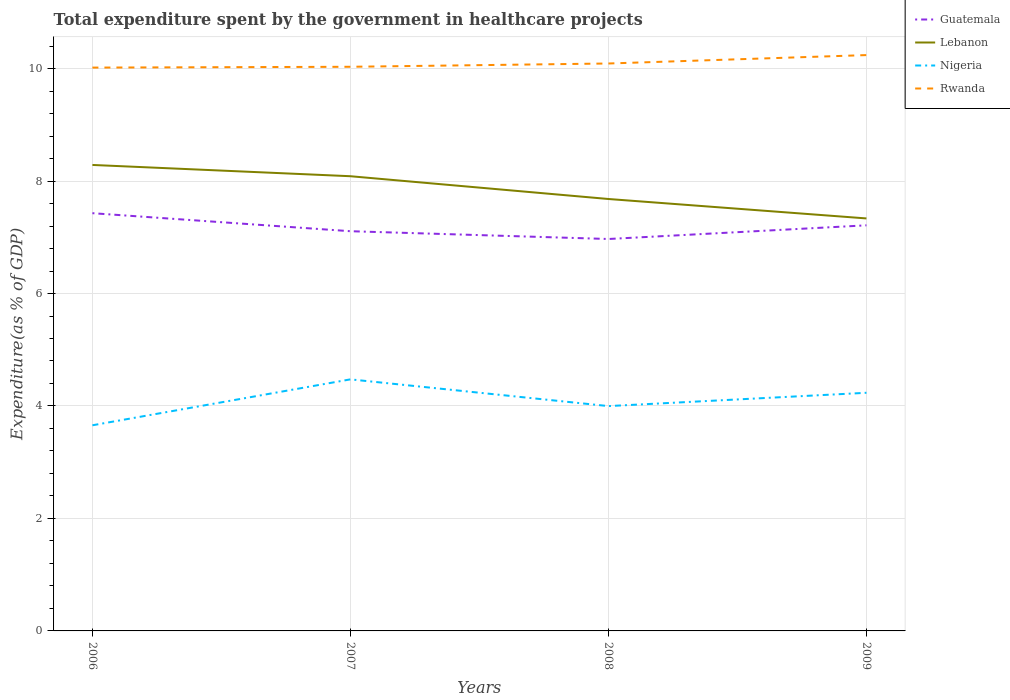Does the line corresponding to Lebanon intersect with the line corresponding to Guatemala?
Give a very brief answer. No. Is the number of lines equal to the number of legend labels?
Offer a terse response. Yes. Across all years, what is the maximum total expenditure spent by the government in healthcare projects in Guatemala?
Give a very brief answer. 6.97. What is the total total expenditure spent by the government in healthcare projects in Guatemala in the graph?
Provide a succinct answer. 0.14. What is the difference between the highest and the second highest total expenditure spent by the government in healthcare projects in Rwanda?
Make the answer very short. 0.22. What is the difference between the highest and the lowest total expenditure spent by the government in healthcare projects in Guatemala?
Make the answer very short. 2. Is the total expenditure spent by the government in healthcare projects in Rwanda strictly greater than the total expenditure spent by the government in healthcare projects in Guatemala over the years?
Ensure brevity in your answer.  No. How many years are there in the graph?
Make the answer very short. 4. Are the values on the major ticks of Y-axis written in scientific E-notation?
Ensure brevity in your answer.  No. Does the graph contain any zero values?
Give a very brief answer. No. Does the graph contain grids?
Your response must be concise. Yes. Where does the legend appear in the graph?
Your answer should be compact. Top right. How are the legend labels stacked?
Provide a short and direct response. Vertical. What is the title of the graph?
Offer a terse response. Total expenditure spent by the government in healthcare projects. Does "Vanuatu" appear as one of the legend labels in the graph?
Offer a terse response. No. What is the label or title of the X-axis?
Keep it short and to the point. Years. What is the label or title of the Y-axis?
Your response must be concise. Expenditure(as % of GDP). What is the Expenditure(as % of GDP) of Guatemala in 2006?
Make the answer very short. 7.43. What is the Expenditure(as % of GDP) in Lebanon in 2006?
Keep it short and to the point. 8.29. What is the Expenditure(as % of GDP) in Nigeria in 2006?
Give a very brief answer. 3.66. What is the Expenditure(as % of GDP) in Rwanda in 2006?
Provide a succinct answer. 10.02. What is the Expenditure(as % of GDP) in Guatemala in 2007?
Make the answer very short. 7.11. What is the Expenditure(as % of GDP) of Lebanon in 2007?
Make the answer very short. 8.09. What is the Expenditure(as % of GDP) in Nigeria in 2007?
Provide a short and direct response. 4.47. What is the Expenditure(as % of GDP) of Rwanda in 2007?
Your response must be concise. 10.03. What is the Expenditure(as % of GDP) in Guatemala in 2008?
Keep it short and to the point. 6.97. What is the Expenditure(as % of GDP) of Lebanon in 2008?
Give a very brief answer. 7.68. What is the Expenditure(as % of GDP) of Nigeria in 2008?
Ensure brevity in your answer.  4. What is the Expenditure(as % of GDP) in Rwanda in 2008?
Provide a short and direct response. 10.09. What is the Expenditure(as % of GDP) of Guatemala in 2009?
Your answer should be very brief. 7.21. What is the Expenditure(as % of GDP) in Lebanon in 2009?
Provide a succinct answer. 7.34. What is the Expenditure(as % of GDP) of Nigeria in 2009?
Make the answer very short. 4.23. What is the Expenditure(as % of GDP) in Rwanda in 2009?
Offer a terse response. 10.24. Across all years, what is the maximum Expenditure(as % of GDP) of Guatemala?
Make the answer very short. 7.43. Across all years, what is the maximum Expenditure(as % of GDP) in Lebanon?
Give a very brief answer. 8.29. Across all years, what is the maximum Expenditure(as % of GDP) of Nigeria?
Make the answer very short. 4.47. Across all years, what is the maximum Expenditure(as % of GDP) of Rwanda?
Your answer should be compact. 10.24. Across all years, what is the minimum Expenditure(as % of GDP) of Guatemala?
Give a very brief answer. 6.97. Across all years, what is the minimum Expenditure(as % of GDP) in Lebanon?
Keep it short and to the point. 7.34. Across all years, what is the minimum Expenditure(as % of GDP) of Nigeria?
Offer a very short reply. 3.66. Across all years, what is the minimum Expenditure(as % of GDP) of Rwanda?
Make the answer very short. 10.02. What is the total Expenditure(as % of GDP) of Guatemala in the graph?
Provide a short and direct response. 28.72. What is the total Expenditure(as % of GDP) of Lebanon in the graph?
Offer a very short reply. 31.39. What is the total Expenditure(as % of GDP) in Nigeria in the graph?
Provide a short and direct response. 16.36. What is the total Expenditure(as % of GDP) of Rwanda in the graph?
Keep it short and to the point. 40.38. What is the difference between the Expenditure(as % of GDP) in Guatemala in 2006 and that in 2007?
Provide a succinct answer. 0.32. What is the difference between the Expenditure(as % of GDP) in Lebanon in 2006 and that in 2007?
Ensure brevity in your answer.  0.2. What is the difference between the Expenditure(as % of GDP) of Nigeria in 2006 and that in 2007?
Your answer should be compact. -0.82. What is the difference between the Expenditure(as % of GDP) of Rwanda in 2006 and that in 2007?
Your answer should be compact. -0.01. What is the difference between the Expenditure(as % of GDP) of Guatemala in 2006 and that in 2008?
Keep it short and to the point. 0.46. What is the difference between the Expenditure(as % of GDP) in Lebanon in 2006 and that in 2008?
Provide a succinct answer. 0.61. What is the difference between the Expenditure(as % of GDP) of Nigeria in 2006 and that in 2008?
Provide a succinct answer. -0.34. What is the difference between the Expenditure(as % of GDP) of Rwanda in 2006 and that in 2008?
Provide a short and direct response. -0.07. What is the difference between the Expenditure(as % of GDP) in Guatemala in 2006 and that in 2009?
Your answer should be compact. 0.22. What is the difference between the Expenditure(as % of GDP) in Lebanon in 2006 and that in 2009?
Make the answer very short. 0.95. What is the difference between the Expenditure(as % of GDP) of Nigeria in 2006 and that in 2009?
Make the answer very short. -0.58. What is the difference between the Expenditure(as % of GDP) in Rwanda in 2006 and that in 2009?
Your answer should be very brief. -0.22. What is the difference between the Expenditure(as % of GDP) in Guatemala in 2007 and that in 2008?
Offer a very short reply. 0.14. What is the difference between the Expenditure(as % of GDP) in Lebanon in 2007 and that in 2008?
Your response must be concise. 0.41. What is the difference between the Expenditure(as % of GDP) of Nigeria in 2007 and that in 2008?
Provide a short and direct response. 0.48. What is the difference between the Expenditure(as % of GDP) in Rwanda in 2007 and that in 2008?
Your answer should be compact. -0.06. What is the difference between the Expenditure(as % of GDP) of Guatemala in 2007 and that in 2009?
Offer a terse response. -0.1. What is the difference between the Expenditure(as % of GDP) in Lebanon in 2007 and that in 2009?
Your answer should be compact. 0.75. What is the difference between the Expenditure(as % of GDP) of Nigeria in 2007 and that in 2009?
Ensure brevity in your answer.  0.24. What is the difference between the Expenditure(as % of GDP) of Rwanda in 2007 and that in 2009?
Offer a very short reply. -0.21. What is the difference between the Expenditure(as % of GDP) of Guatemala in 2008 and that in 2009?
Offer a terse response. -0.24. What is the difference between the Expenditure(as % of GDP) of Lebanon in 2008 and that in 2009?
Your answer should be compact. 0.35. What is the difference between the Expenditure(as % of GDP) in Nigeria in 2008 and that in 2009?
Provide a short and direct response. -0.24. What is the difference between the Expenditure(as % of GDP) of Rwanda in 2008 and that in 2009?
Provide a short and direct response. -0.15. What is the difference between the Expenditure(as % of GDP) in Guatemala in 2006 and the Expenditure(as % of GDP) in Lebanon in 2007?
Provide a succinct answer. -0.66. What is the difference between the Expenditure(as % of GDP) of Guatemala in 2006 and the Expenditure(as % of GDP) of Nigeria in 2007?
Give a very brief answer. 2.96. What is the difference between the Expenditure(as % of GDP) of Guatemala in 2006 and the Expenditure(as % of GDP) of Rwanda in 2007?
Your response must be concise. -2.6. What is the difference between the Expenditure(as % of GDP) in Lebanon in 2006 and the Expenditure(as % of GDP) in Nigeria in 2007?
Keep it short and to the point. 3.81. What is the difference between the Expenditure(as % of GDP) in Lebanon in 2006 and the Expenditure(as % of GDP) in Rwanda in 2007?
Your response must be concise. -1.75. What is the difference between the Expenditure(as % of GDP) in Nigeria in 2006 and the Expenditure(as % of GDP) in Rwanda in 2007?
Keep it short and to the point. -6.38. What is the difference between the Expenditure(as % of GDP) in Guatemala in 2006 and the Expenditure(as % of GDP) in Lebanon in 2008?
Ensure brevity in your answer.  -0.25. What is the difference between the Expenditure(as % of GDP) in Guatemala in 2006 and the Expenditure(as % of GDP) in Nigeria in 2008?
Offer a terse response. 3.43. What is the difference between the Expenditure(as % of GDP) in Guatemala in 2006 and the Expenditure(as % of GDP) in Rwanda in 2008?
Offer a very short reply. -2.66. What is the difference between the Expenditure(as % of GDP) of Lebanon in 2006 and the Expenditure(as % of GDP) of Nigeria in 2008?
Your answer should be very brief. 4.29. What is the difference between the Expenditure(as % of GDP) of Lebanon in 2006 and the Expenditure(as % of GDP) of Rwanda in 2008?
Your answer should be compact. -1.8. What is the difference between the Expenditure(as % of GDP) in Nigeria in 2006 and the Expenditure(as % of GDP) in Rwanda in 2008?
Make the answer very short. -6.43. What is the difference between the Expenditure(as % of GDP) in Guatemala in 2006 and the Expenditure(as % of GDP) in Lebanon in 2009?
Keep it short and to the point. 0.09. What is the difference between the Expenditure(as % of GDP) in Guatemala in 2006 and the Expenditure(as % of GDP) in Nigeria in 2009?
Your response must be concise. 3.19. What is the difference between the Expenditure(as % of GDP) in Guatemala in 2006 and the Expenditure(as % of GDP) in Rwanda in 2009?
Provide a succinct answer. -2.81. What is the difference between the Expenditure(as % of GDP) of Lebanon in 2006 and the Expenditure(as % of GDP) of Nigeria in 2009?
Provide a succinct answer. 4.05. What is the difference between the Expenditure(as % of GDP) of Lebanon in 2006 and the Expenditure(as % of GDP) of Rwanda in 2009?
Provide a succinct answer. -1.95. What is the difference between the Expenditure(as % of GDP) in Nigeria in 2006 and the Expenditure(as % of GDP) in Rwanda in 2009?
Provide a short and direct response. -6.58. What is the difference between the Expenditure(as % of GDP) of Guatemala in 2007 and the Expenditure(as % of GDP) of Lebanon in 2008?
Make the answer very short. -0.57. What is the difference between the Expenditure(as % of GDP) of Guatemala in 2007 and the Expenditure(as % of GDP) of Nigeria in 2008?
Keep it short and to the point. 3.11. What is the difference between the Expenditure(as % of GDP) of Guatemala in 2007 and the Expenditure(as % of GDP) of Rwanda in 2008?
Your response must be concise. -2.98. What is the difference between the Expenditure(as % of GDP) in Lebanon in 2007 and the Expenditure(as % of GDP) in Nigeria in 2008?
Your response must be concise. 4.09. What is the difference between the Expenditure(as % of GDP) in Lebanon in 2007 and the Expenditure(as % of GDP) in Rwanda in 2008?
Your answer should be compact. -2. What is the difference between the Expenditure(as % of GDP) of Nigeria in 2007 and the Expenditure(as % of GDP) of Rwanda in 2008?
Offer a very short reply. -5.62. What is the difference between the Expenditure(as % of GDP) of Guatemala in 2007 and the Expenditure(as % of GDP) of Lebanon in 2009?
Offer a terse response. -0.23. What is the difference between the Expenditure(as % of GDP) in Guatemala in 2007 and the Expenditure(as % of GDP) in Nigeria in 2009?
Your response must be concise. 2.87. What is the difference between the Expenditure(as % of GDP) of Guatemala in 2007 and the Expenditure(as % of GDP) of Rwanda in 2009?
Your answer should be very brief. -3.13. What is the difference between the Expenditure(as % of GDP) in Lebanon in 2007 and the Expenditure(as % of GDP) in Nigeria in 2009?
Offer a terse response. 3.85. What is the difference between the Expenditure(as % of GDP) in Lebanon in 2007 and the Expenditure(as % of GDP) in Rwanda in 2009?
Your response must be concise. -2.15. What is the difference between the Expenditure(as % of GDP) of Nigeria in 2007 and the Expenditure(as % of GDP) of Rwanda in 2009?
Provide a short and direct response. -5.77. What is the difference between the Expenditure(as % of GDP) in Guatemala in 2008 and the Expenditure(as % of GDP) in Lebanon in 2009?
Offer a very short reply. -0.37. What is the difference between the Expenditure(as % of GDP) of Guatemala in 2008 and the Expenditure(as % of GDP) of Nigeria in 2009?
Your response must be concise. 2.73. What is the difference between the Expenditure(as % of GDP) in Guatemala in 2008 and the Expenditure(as % of GDP) in Rwanda in 2009?
Give a very brief answer. -3.27. What is the difference between the Expenditure(as % of GDP) in Lebanon in 2008 and the Expenditure(as % of GDP) in Nigeria in 2009?
Ensure brevity in your answer.  3.45. What is the difference between the Expenditure(as % of GDP) of Lebanon in 2008 and the Expenditure(as % of GDP) of Rwanda in 2009?
Offer a terse response. -2.56. What is the difference between the Expenditure(as % of GDP) of Nigeria in 2008 and the Expenditure(as % of GDP) of Rwanda in 2009?
Give a very brief answer. -6.24. What is the average Expenditure(as % of GDP) in Guatemala per year?
Your response must be concise. 7.18. What is the average Expenditure(as % of GDP) in Lebanon per year?
Keep it short and to the point. 7.85. What is the average Expenditure(as % of GDP) of Nigeria per year?
Keep it short and to the point. 4.09. What is the average Expenditure(as % of GDP) in Rwanda per year?
Your answer should be very brief. 10.09. In the year 2006, what is the difference between the Expenditure(as % of GDP) of Guatemala and Expenditure(as % of GDP) of Lebanon?
Give a very brief answer. -0.86. In the year 2006, what is the difference between the Expenditure(as % of GDP) in Guatemala and Expenditure(as % of GDP) in Nigeria?
Your response must be concise. 3.77. In the year 2006, what is the difference between the Expenditure(as % of GDP) in Guatemala and Expenditure(as % of GDP) in Rwanda?
Provide a succinct answer. -2.59. In the year 2006, what is the difference between the Expenditure(as % of GDP) in Lebanon and Expenditure(as % of GDP) in Nigeria?
Offer a very short reply. 4.63. In the year 2006, what is the difference between the Expenditure(as % of GDP) of Lebanon and Expenditure(as % of GDP) of Rwanda?
Your response must be concise. -1.73. In the year 2006, what is the difference between the Expenditure(as % of GDP) in Nigeria and Expenditure(as % of GDP) in Rwanda?
Your answer should be compact. -6.36. In the year 2007, what is the difference between the Expenditure(as % of GDP) in Guatemala and Expenditure(as % of GDP) in Lebanon?
Ensure brevity in your answer.  -0.98. In the year 2007, what is the difference between the Expenditure(as % of GDP) of Guatemala and Expenditure(as % of GDP) of Nigeria?
Keep it short and to the point. 2.63. In the year 2007, what is the difference between the Expenditure(as % of GDP) in Guatemala and Expenditure(as % of GDP) in Rwanda?
Your answer should be very brief. -2.92. In the year 2007, what is the difference between the Expenditure(as % of GDP) of Lebanon and Expenditure(as % of GDP) of Nigeria?
Give a very brief answer. 3.61. In the year 2007, what is the difference between the Expenditure(as % of GDP) of Lebanon and Expenditure(as % of GDP) of Rwanda?
Keep it short and to the point. -1.95. In the year 2007, what is the difference between the Expenditure(as % of GDP) in Nigeria and Expenditure(as % of GDP) in Rwanda?
Ensure brevity in your answer.  -5.56. In the year 2008, what is the difference between the Expenditure(as % of GDP) in Guatemala and Expenditure(as % of GDP) in Lebanon?
Ensure brevity in your answer.  -0.71. In the year 2008, what is the difference between the Expenditure(as % of GDP) of Guatemala and Expenditure(as % of GDP) of Nigeria?
Your answer should be very brief. 2.97. In the year 2008, what is the difference between the Expenditure(as % of GDP) in Guatemala and Expenditure(as % of GDP) in Rwanda?
Your answer should be very brief. -3.12. In the year 2008, what is the difference between the Expenditure(as % of GDP) of Lebanon and Expenditure(as % of GDP) of Nigeria?
Your response must be concise. 3.68. In the year 2008, what is the difference between the Expenditure(as % of GDP) of Lebanon and Expenditure(as % of GDP) of Rwanda?
Make the answer very short. -2.41. In the year 2008, what is the difference between the Expenditure(as % of GDP) in Nigeria and Expenditure(as % of GDP) in Rwanda?
Offer a very short reply. -6.09. In the year 2009, what is the difference between the Expenditure(as % of GDP) in Guatemala and Expenditure(as % of GDP) in Lebanon?
Make the answer very short. -0.12. In the year 2009, what is the difference between the Expenditure(as % of GDP) of Guatemala and Expenditure(as % of GDP) of Nigeria?
Provide a short and direct response. 2.98. In the year 2009, what is the difference between the Expenditure(as % of GDP) in Guatemala and Expenditure(as % of GDP) in Rwanda?
Keep it short and to the point. -3.03. In the year 2009, what is the difference between the Expenditure(as % of GDP) of Lebanon and Expenditure(as % of GDP) of Nigeria?
Ensure brevity in your answer.  3.1. In the year 2009, what is the difference between the Expenditure(as % of GDP) in Lebanon and Expenditure(as % of GDP) in Rwanda?
Provide a short and direct response. -2.9. In the year 2009, what is the difference between the Expenditure(as % of GDP) of Nigeria and Expenditure(as % of GDP) of Rwanda?
Provide a succinct answer. -6.01. What is the ratio of the Expenditure(as % of GDP) in Guatemala in 2006 to that in 2007?
Ensure brevity in your answer.  1.05. What is the ratio of the Expenditure(as % of GDP) of Lebanon in 2006 to that in 2007?
Ensure brevity in your answer.  1.02. What is the ratio of the Expenditure(as % of GDP) of Nigeria in 2006 to that in 2007?
Offer a very short reply. 0.82. What is the ratio of the Expenditure(as % of GDP) of Guatemala in 2006 to that in 2008?
Your response must be concise. 1.07. What is the ratio of the Expenditure(as % of GDP) in Lebanon in 2006 to that in 2008?
Make the answer very short. 1.08. What is the ratio of the Expenditure(as % of GDP) of Nigeria in 2006 to that in 2008?
Your answer should be compact. 0.91. What is the ratio of the Expenditure(as % of GDP) in Guatemala in 2006 to that in 2009?
Offer a very short reply. 1.03. What is the ratio of the Expenditure(as % of GDP) of Lebanon in 2006 to that in 2009?
Ensure brevity in your answer.  1.13. What is the ratio of the Expenditure(as % of GDP) in Nigeria in 2006 to that in 2009?
Your response must be concise. 0.86. What is the ratio of the Expenditure(as % of GDP) in Rwanda in 2006 to that in 2009?
Ensure brevity in your answer.  0.98. What is the ratio of the Expenditure(as % of GDP) in Guatemala in 2007 to that in 2008?
Your answer should be very brief. 1.02. What is the ratio of the Expenditure(as % of GDP) in Lebanon in 2007 to that in 2008?
Give a very brief answer. 1.05. What is the ratio of the Expenditure(as % of GDP) in Nigeria in 2007 to that in 2008?
Provide a short and direct response. 1.12. What is the ratio of the Expenditure(as % of GDP) of Rwanda in 2007 to that in 2008?
Provide a short and direct response. 0.99. What is the ratio of the Expenditure(as % of GDP) in Guatemala in 2007 to that in 2009?
Ensure brevity in your answer.  0.99. What is the ratio of the Expenditure(as % of GDP) of Lebanon in 2007 to that in 2009?
Give a very brief answer. 1.1. What is the ratio of the Expenditure(as % of GDP) in Nigeria in 2007 to that in 2009?
Make the answer very short. 1.06. What is the ratio of the Expenditure(as % of GDP) of Rwanda in 2007 to that in 2009?
Your answer should be very brief. 0.98. What is the ratio of the Expenditure(as % of GDP) of Guatemala in 2008 to that in 2009?
Your answer should be compact. 0.97. What is the ratio of the Expenditure(as % of GDP) in Lebanon in 2008 to that in 2009?
Your response must be concise. 1.05. What is the ratio of the Expenditure(as % of GDP) in Nigeria in 2008 to that in 2009?
Provide a succinct answer. 0.94. What is the ratio of the Expenditure(as % of GDP) in Rwanda in 2008 to that in 2009?
Offer a terse response. 0.99. What is the difference between the highest and the second highest Expenditure(as % of GDP) in Guatemala?
Your response must be concise. 0.22. What is the difference between the highest and the second highest Expenditure(as % of GDP) of Lebanon?
Keep it short and to the point. 0.2. What is the difference between the highest and the second highest Expenditure(as % of GDP) in Nigeria?
Make the answer very short. 0.24. What is the difference between the highest and the second highest Expenditure(as % of GDP) in Rwanda?
Keep it short and to the point. 0.15. What is the difference between the highest and the lowest Expenditure(as % of GDP) in Guatemala?
Provide a succinct answer. 0.46. What is the difference between the highest and the lowest Expenditure(as % of GDP) in Lebanon?
Provide a succinct answer. 0.95. What is the difference between the highest and the lowest Expenditure(as % of GDP) of Nigeria?
Your response must be concise. 0.82. What is the difference between the highest and the lowest Expenditure(as % of GDP) of Rwanda?
Offer a terse response. 0.22. 